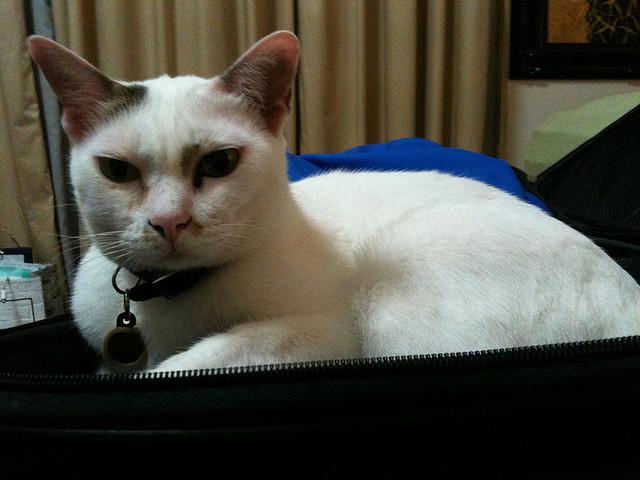What design is on the wall behind the cat?
Answer briefly. Stripes. What color is the white cats collar?
Keep it brief. Black. How many baskets are on the dresser?
Be succinct. 0. What color is the cat?
Concise answer only. White. What does the cat's tag say?
Give a very brief answer. Name. Is the cat playing?
Short answer required. No. 